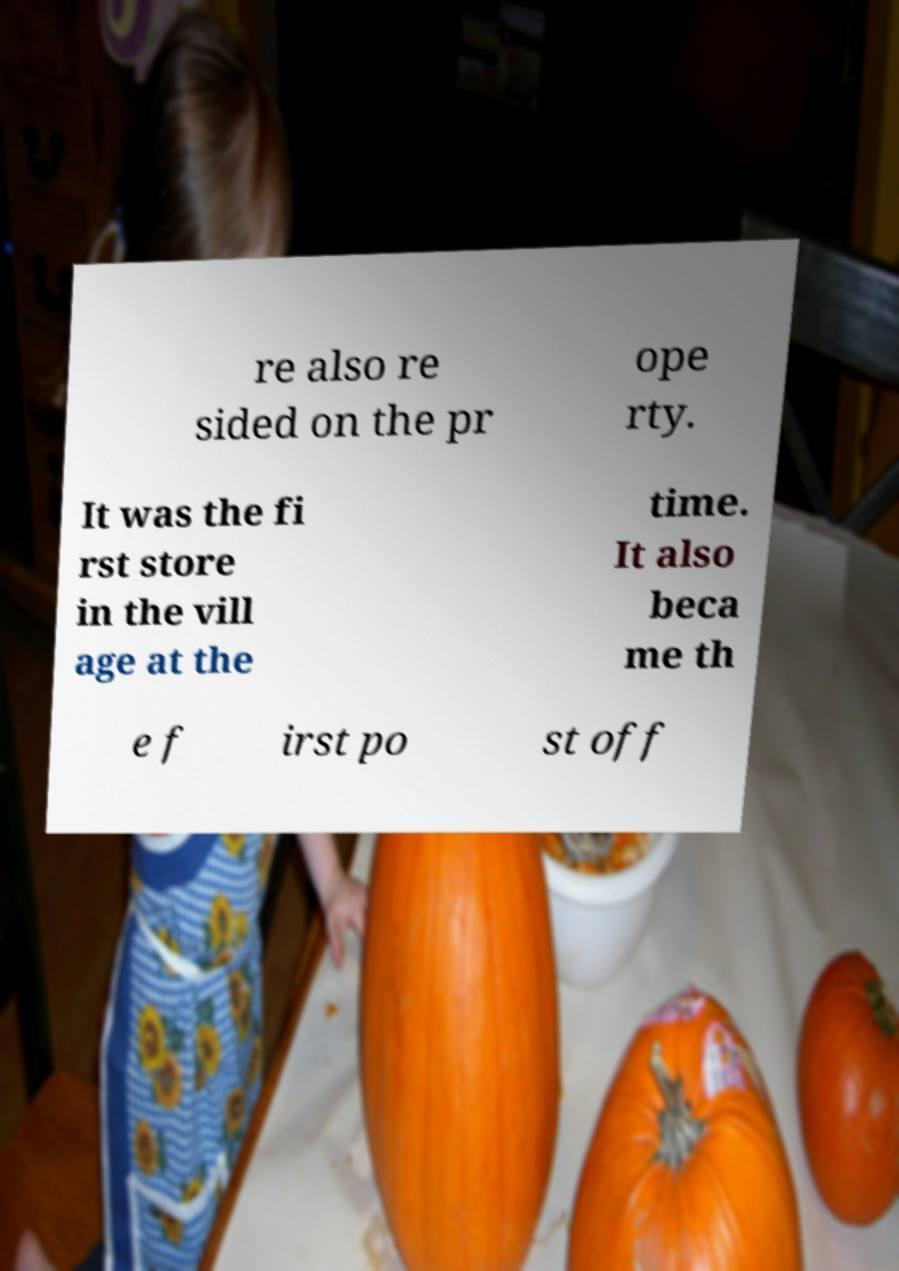For documentation purposes, I need the text within this image transcribed. Could you provide that? re also re sided on the pr ope rty. It was the fi rst store in the vill age at the time. It also beca me th e f irst po st off 